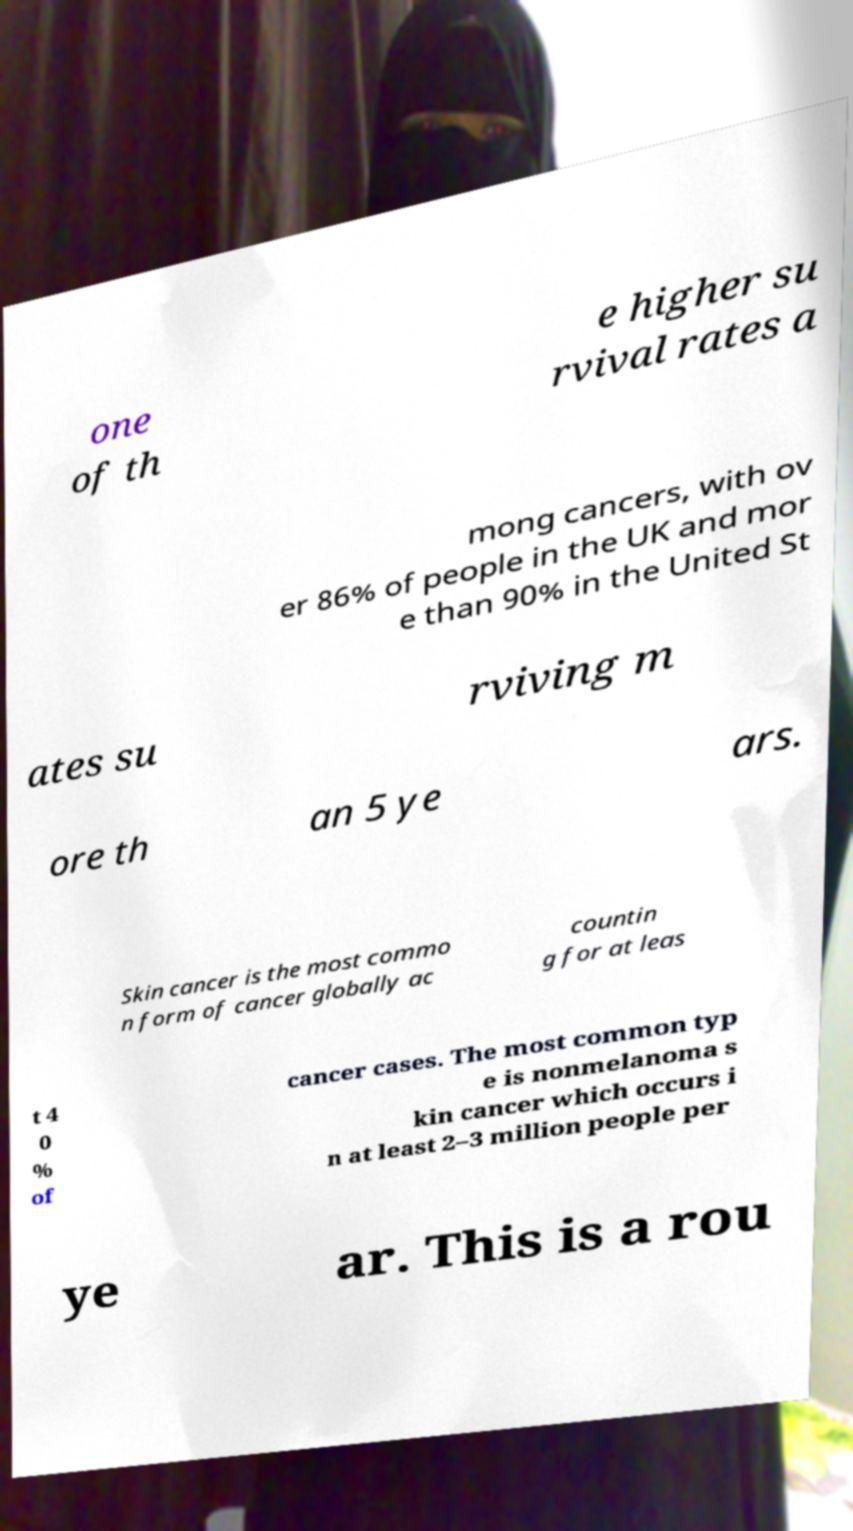Please identify and transcribe the text found in this image. one of th e higher su rvival rates a mong cancers, with ov er 86% of people in the UK and mor e than 90% in the United St ates su rviving m ore th an 5 ye ars. Skin cancer is the most commo n form of cancer globally ac countin g for at leas t 4 0 % of cancer cases. The most common typ e is nonmelanoma s kin cancer which occurs i n at least 2–3 million people per ye ar. This is a rou 